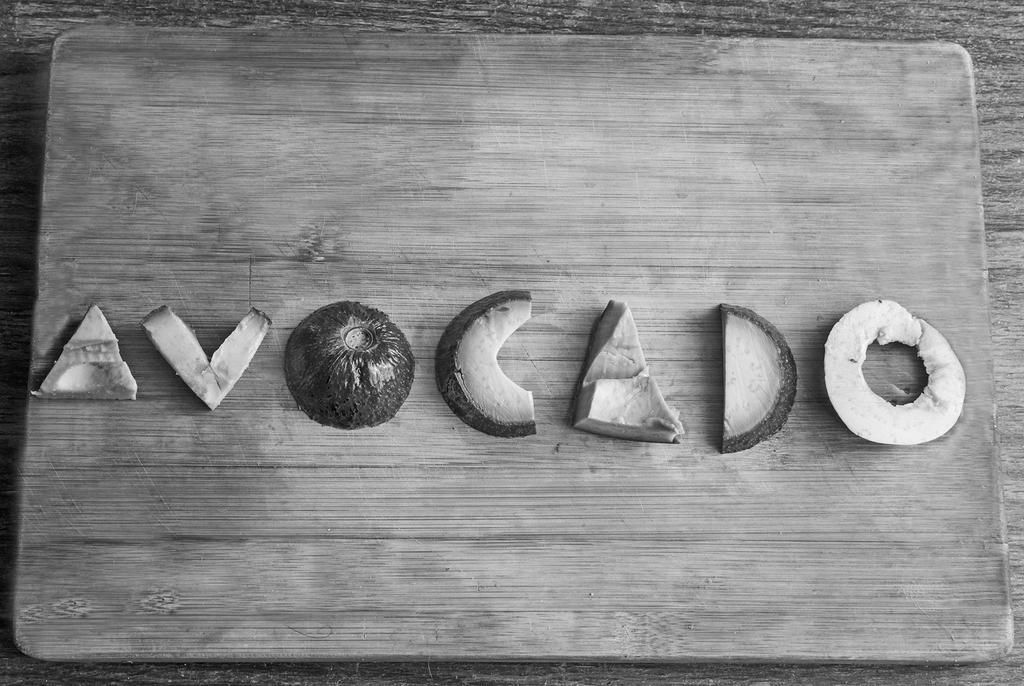In one or two sentences, can you explain what this image depicts? In this image we can see some fruit pieces placed on a wooden surface. 